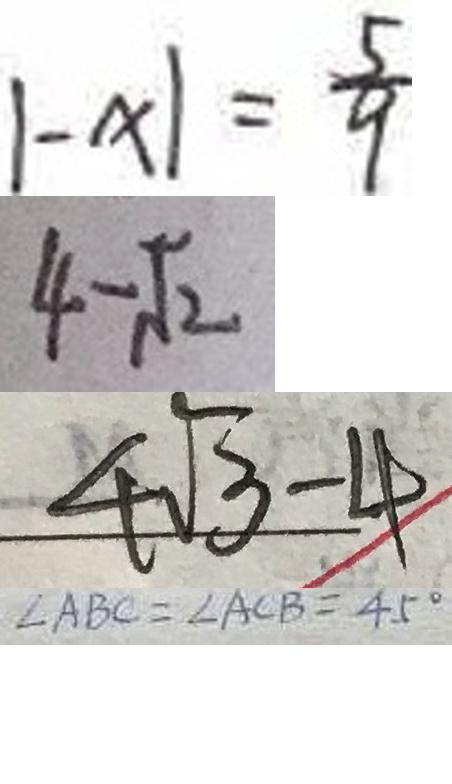<formula> <loc_0><loc_0><loc_500><loc_500>\vert - x \vert = \frac { 5 } { 9 } 
 4 - \sqrt { 2 } 
 4 \sqrt { 3 } - 4 
 \angle A B C = \angle A C B = 4 5 ^ { \circ }</formula> 